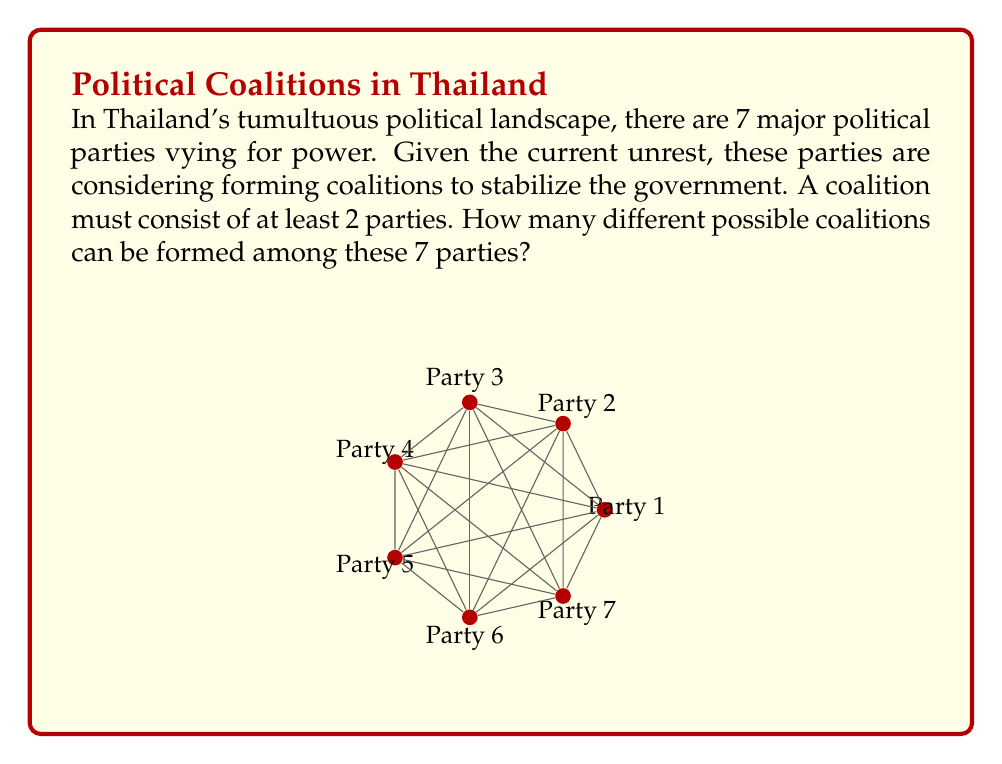Could you help me with this problem? Let's approach this step-by-step:

1) First, we need to understand that a coalition can be any subset of the 7 parties, as long as it contains at least 2 parties.

2) The total number of subsets of a set with n elements is $2^n$. This includes the empty set and the full set.

3) In this case, we have 7 parties, so the total number of subsets would be $2^7 = 128$.

4) However, we don't want to include:
   - The empty set (no parties)
   - The 7 single-party "coalitions" (as a coalition must have at least 2 parties)

5) Therefore, we need to subtract these from our total:

   $\text{Number of valid coalitions} = 2^7 - 1 - 7 = 128 - 1 - 7 = 120$

6) We can express this generally as:

   $\text{Number of coalitions} = 2^n - n - 1$

   Where n is the number of parties.

Thus, among 7 parties, there are 120 possible coalitions that can be formed.
Answer: 120 